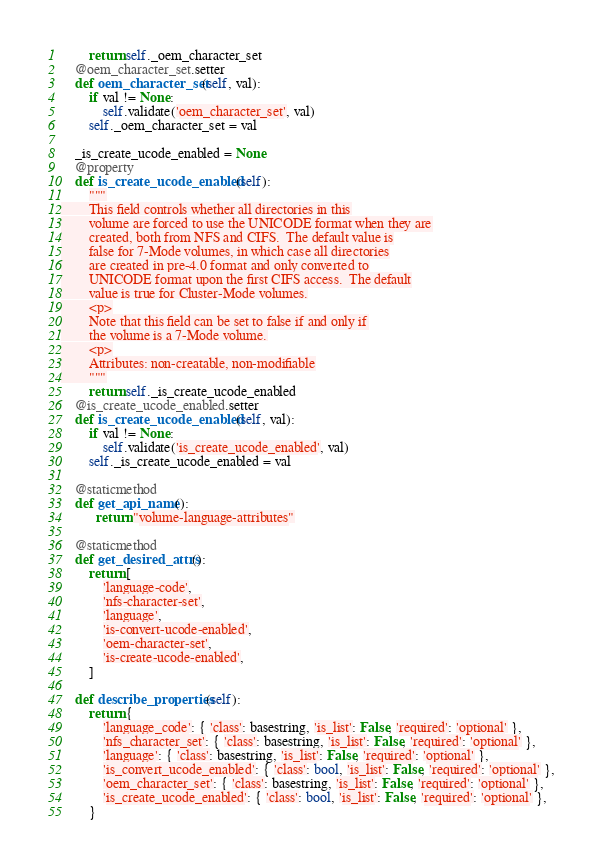Convert code to text. <code><loc_0><loc_0><loc_500><loc_500><_Python_>        return self._oem_character_set
    @oem_character_set.setter
    def oem_character_set(self, val):
        if val != None:
            self.validate('oem_character_set', val)
        self._oem_character_set = val
    
    _is_create_ucode_enabled = None
    @property
    def is_create_ucode_enabled(self):
        """
        This field controls whether all directories in this
        volume are forced to use the UNICODE format when they are
        created, both from NFS and CIFS.  The default value is
        false for 7-Mode volumes, in which case all directories
        are created in pre-4.0 format and only converted to
        UNICODE format upon the first CIFS access.  The default
        value is true for Cluster-Mode volumes.
        <p>
        Note that this field can be set to false if and only if
        the volume is a 7-Mode volume.
        <p>
        Attributes: non-creatable, non-modifiable
        """
        return self._is_create_ucode_enabled
    @is_create_ucode_enabled.setter
    def is_create_ucode_enabled(self, val):
        if val != None:
            self.validate('is_create_ucode_enabled', val)
        self._is_create_ucode_enabled = val
    
    @staticmethod
    def get_api_name():
          return "volume-language-attributes"
    
    @staticmethod
    def get_desired_attrs():
        return [
            'language-code',
            'nfs-character-set',
            'language',
            'is-convert-ucode-enabled',
            'oem-character-set',
            'is-create-ucode-enabled',
        ]
    
    def describe_properties(self):
        return {
            'language_code': { 'class': basestring, 'is_list': False, 'required': 'optional' },
            'nfs_character_set': { 'class': basestring, 'is_list': False, 'required': 'optional' },
            'language': { 'class': basestring, 'is_list': False, 'required': 'optional' },
            'is_convert_ucode_enabled': { 'class': bool, 'is_list': False, 'required': 'optional' },
            'oem_character_set': { 'class': basestring, 'is_list': False, 'required': 'optional' },
            'is_create_ucode_enabled': { 'class': bool, 'is_list': False, 'required': 'optional' },
        }
</code> 